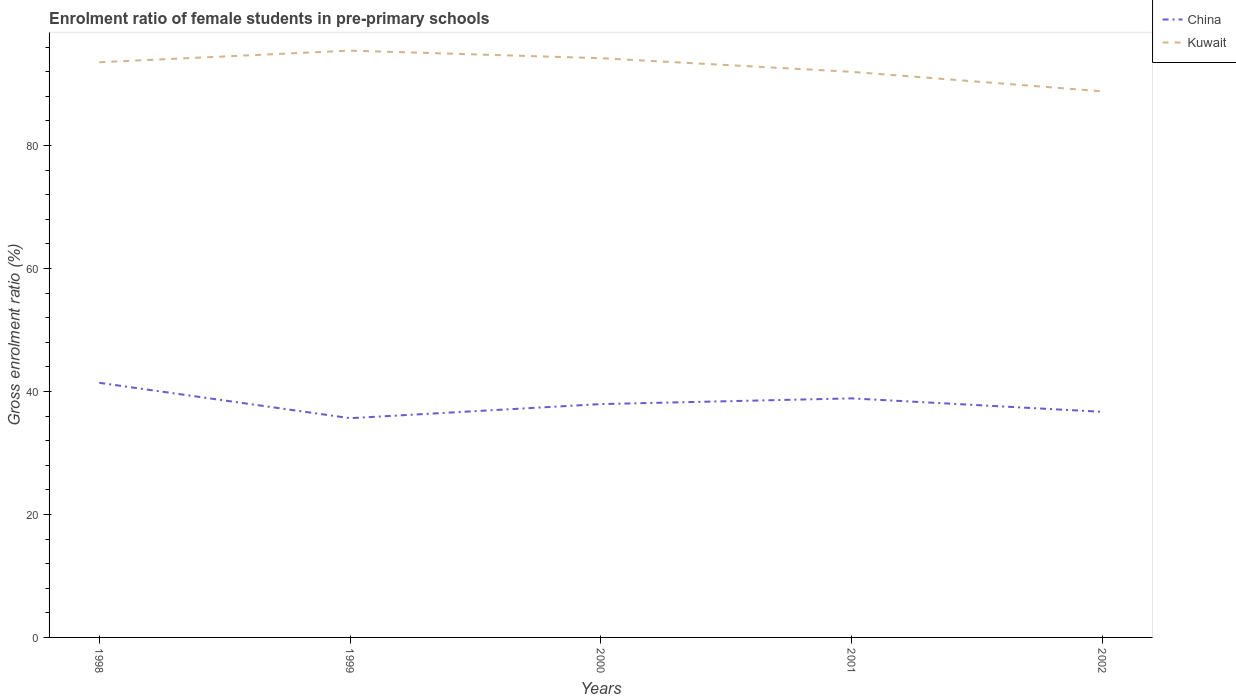How many different coloured lines are there?
Provide a short and direct response. 2. Across all years, what is the maximum enrolment ratio of female students in pre-primary schools in China?
Offer a terse response. 35.65. What is the total enrolment ratio of female students in pre-primary schools in Kuwait in the graph?
Your answer should be very brief. 5.39. What is the difference between the highest and the second highest enrolment ratio of female students in pre-primary schools in China?
Provide a short and direct response. 5.75. Is the enrolment ratio of female students in pre-primary schools in China strictly greater than the enrolment ratio of female students in pre-primary schools in Kuwait over the years?
Make the answer very short. Yes. How many lines are there?
Your response must be concise. 2. What is the difference between two consecutive major ticks on the Y-axis?
Keep it short and to the point. 20. Does the graph contain grids?
Your answer should be compact. No. Where does the legend appear in the graph?
Your answer should be compact. Top right. How many legend labels are there?
Offer a very short reply. 2. What is the title of the graph?
Your answer should be very brief. Enrolment ratio of female students in pre-primary schools. What is the Gross enrolment ratio (%) of China in 1998?
Give a very brief answer. 41.4. What is the Gross enrolment ratio (%) of Kuwait in 1998?
Ensure brevity in your answer.  93.53. What is the Gross enrolment ratio (%) in China in 1999?
Ensure brevity in your answer.  35.65. What is the Gross enrolment ratio (%) in Kuwait in 1999?
Your answer should be compact. 95.42. What is the Gross enrolment ratio (%) of China in 2000?
Give a very brief answer. 37.94. What is the Gross enrolment ratio (%) of Kuwait in 2000?
Offer a very short reply. 94.19. What is the Gross enrolment ratio (%) of China in 2001?
Your answer should be very brief. 38.87. What is the Gross enrolment ratio (%) in Kuwait in 2001?
Your answer should be very brief. 91.97. What is the Gross enrolment ratio (%) of China in 2002?
Offer a very short reply. 36.68. What is the Gross enrolment ratio (%) of Kuwait in 2002?
Provide a succinct answer. 88.8. Across all years, what is the maximum Gross enrolment ratio (%) of China?
Give a very brief answer. 41.4. Across all years, what is the maximum Gross enrolment ratio (%) in Kuwait?
Provide a succinct answer. 95.42. Across all years, what is the minimum Gross enrolment ratio (%) in China?
Your answer should be compact. 35.65. Across all years, what is the minimum Gross enrolment ratio (%) in Kuwait?
Your answer should be compact. 88.8. What is the total Gross enrolment ratio (%) of China in the graph?
Provide a short and direct response. 190.55. What is the total Gross enrolment ratio (%) in Kuwait in the graph?
Offer a terse response. 463.91. What is the difference between the Gross enrolment ratio (%) of China in 1998 and that in 1999?
Your answer should be compact. 5.75. What is the difference between the Gross enrolment ratio (%) of Kuwait in 1998 and that in 1999?
Your answer should be compact. -1.89. What is the difference between the Gross enrolment ratio (%) of China in 1998 and that in 2000?
Provide a succinct answer. 3.46. What is the difference between the Gross enrolment ratio (%) in Kuwait in 1998 and that in 2000?
Ensure brevity in your answer.  -0.66. What is the difference between the Gross enrolment ratio (%) in China in 1998 and that in 2001?
Your response must be concise. 2.53. What is the difference between the Gross enrolment ratio (%) of Kuwait in 1998 and that in 2001?
Provide a short and direct response. 1.56. What is the difference between the Gross enrolment ratio (%) in China in 1998 and that in 2002?
Your answer should be very brief. 4.72. What is the difference between the Gross enrolment ratio (%) in Kuwait in 1998 and that in 2002?
Provide a short and direct response. 4.73. What is the difference between the Gross enrolment ratio (%) in China in 1999 and that in 2000?
Your answer should be compact. -2.29. What is the difference between the Gross enrolment ratio (%) of Kuwait in 1999 and that in 2000?
Ensure brevity in your answer.  1.23. What is the difference between the Gross enrolment ratio (%) in China in 1999 and that in 2001?
Ensure brevity in your answer.  -3.22. What is the difference between the Gross enrolment ratio (%) in Kuwait in 1999 and that in 2001?
Give a very brief answer. 3.45. What is the difference between the Gross enrolment ratio (%) of China in 1999 and that in 2002?
Keep it short and to the point. -1.03. What is the difference between the Gross enrolment ratio (%) in Kuwait in 1999 and that in 2002?
Offer a terse response. 6.62. What is the difference between the Gross enrolment ratio (%) in China in 2000 and that in 2001?
Offer a very short reply. -0.93. What is the difference between the Gross enrolment ratio (%) of Kuwait in 2000 and that in 2001?
Give a very brief answer. 2.22. What is the difference between the Gross enrolment ratio (%) of China in 2000 and that in 2002?
Offer a terse response. 1.26. What is the difference between the Gross enrolment ratio (%) in Kuwait in 2000 and that in 2002?
Your answer should be very brief. 5.39. What is the difference between the Gross enrolment ratio (%) in China in 2001 and that in 2002?
Ensure brevity in your answer.  2.19. What is the difference between the Gross enrolment ratio (%) of Kuwait in 2001 and that in 2002?
Offer a terse response. 3.17. What is the difference between the Gross enrolment ratio (%) of China in 1998 and the Gross enrolment ratio (%) of Kuwait in 1999?
Give a very brief answer. -54.02. What is the difference between the Gross enrolment ratio (%) in China in 1998 and the Gross enrolment ratio (%) in Kuwait in 2000?
Your answer should be very brief. -52.78. What is the difference between the Gross enrolment ratio (%) in China in 1998 and the Gross enrolment ratio (%) in Kuwait in 2001?
Keep it short and to the point. -50.57. What is the difference between the Gross enrolment ratio (%) of China in 1998 and the Gross enrolment ratio (%) of Kuwait in 2002?
Offer a very short reply. -47.4. What is the difference between the Gross enrolment ratio (%) in China in 1999 and the Gross enrolment ratio (%) in Kuwait in 2000?
Offer a terse response. -58.54. What is the difference between the Gross enrolment ratio (%) of China in 1999 and the Gross enrolment ratio (%) of Kuwait in 2001?
Your answer should be compact. -56.32. What is the difference between the Gross enrolment ratio (%) of China in 1999 and the Gross enrolment ratio (%) of Kuwait in 2002?
Make the answer very short. -53.15. What is the difference between the Gross enrolment ratio (%) of China in 2000 and the Gross enrolment ratio (%) of Kuwait in 2001?
Your response must be concise. -54.03. What is the difference between the Gross enrolment ratio (%) of China in 2000 and the Gross enrolment ratio (%) of Kuwait in 2002?
Your answer should be compact. -50.86. What is the difference between the Gross enrolment ratio (%) of China in 2001 and the Gross enrolment ratio (%) of Kuwait in 2002?
Offer a very short reply. -49.93. What is the average Gross enrolment ratio (%) in China per year?
Your response must be concise. 38.11. What is the average Gross enrolment ratio (%) of Kuwait per year?
Ensure brevity in your answer.  92.78. In the year 1998, what is the difference between the Gross enrolment ratio (%) of China and Gross enrolment ratio (%) of Kuwait?
Make the answer very short. -52.13. In the year 1999, what is the difference between the Gross enrolment ratio (%) of China and Gross enrolment ratio (%) of Kuwait?
Ensure brevity in your answer.  -59.77. In the year 2000, what is the difference between the Gross enrolment ratio (%) of China and Gross enrolment ratio (%) of Kuwait?
Provide a short and direct response. -56.25. In the year 2001, what is the difference between the Gross enrolment ratio (%) in China and Gross enrolment ratio (%) in Kuwait?
Your answer should be very brief. -53.1. In the year 2002, what is the difference between the Gross enrolment ratio (%) in China and Gross enrolment ratio (%) in Kuwait?
Your answer should be compact. -52.12. What is the ratio of the Gross enrolment ratio (%) of China in 1998 to that in 1999?
Make the answer very short. 1.16. What is the ratio of the Gross enrolment ratio (%) in Kuwait in 1998 to that in 1999?
Give a very brief answer. 0.98. What is the ratio of the Gross enrolment ratio (%) of China in 1998 to that in 2000?
Provide a short and direct response. 1.09. What is the ratio of the Gross enrolment ratio (%) of Kuwait in 1998 to that in 2000?
Give a very brief answer. 0.99. What is the ratio of the Gross enrolment ratio (%) in China in 1998 to that in 2001?
Provide a succinct answer. 1.07. What is the ratio of the Gross enrolment ratio (%) in Kuwait in 1998 to that in 2001?
Your response must be concise. 1.02. What is the ratio of the Gross enrolment ratio (%) in China in 1998 to that in 2002?
Keep it short and to the point. 1.13. What is the ratio of the Gross enrolment ratio (%) of Kuwait in 1998 to that in 2002?
Provide a succinct answer. 1.05. What is the ratio of the Gross enrolment ratio (%) in China in 1999 to that in 2000?
Your answer should be very brief. 0.94. What is the ratio of the Gross enrolment ratio (%) in Kuwait in 1999 to that in 2000?
Your answer should be very brief. 1.01. What is the ratio of the Gross enrolment ratio (%) in China in 1999 to that in 2001?
Give a very brief answer. 0.92. What is the ratio of the Gross enrolment ratio (%) in Kuwait in 1999 to that in 2001?
Offer a very short reply. 1.04. What is the ratio of the Gross enrolment ratio (%) of China in 1999 to that in 2002?
Provide a short and direct response. 0.97. What is the ratio of the Gross enrolment ratio (%) in Kuwait in 1999 to that in 2002?
Provide a short and direct response. 1.07. What is the ratio of the Gross enrolment ratio (%) of China in 2000 to that in 2001?
Give a very brief answer. 0.98. What is the ratio of the Gross enrolment ratio (%) of Kuwait in 2000 to that in 2001?
Ensure brevity in your answer.  1.02. What is the ratio of the Gross enrolment ratio (%) in China in 2000 to that in 2002?
Provide a short and direct response. 1.03. What is the ratio of the Gross enrolment ratio (%) in Kuwait in 2000 to that in 2002?
Give a very brief answer. 1.06. What is the ratio of the Gross enrolment ratio (%) in China in 2001 to that in 2002?
Keep it short and to the point. 1.06. What is the ratio of the Gross enrolment ratio (%) in Kuwait in 2001 to that in 2002?
Ensure brevity in your answer.  1.04. What is the difference between the highest and the second highest Gross enrolment ratio (%) in China?
Offer a terse response. 2.53. What is the difference between the highest and the second highest Gross enrolment ratio (%) in Kuwait?
Your answer should be compact. 1.23. What is the difference between the highest and the lowest Gross enrolment ratio (%) of China?
Provide a succinct answer. 5.75. What is the difference between the highest and the lowest Gross enrolment ratio (%) in Kuwait?
Your answer should be compact. 6.62. 